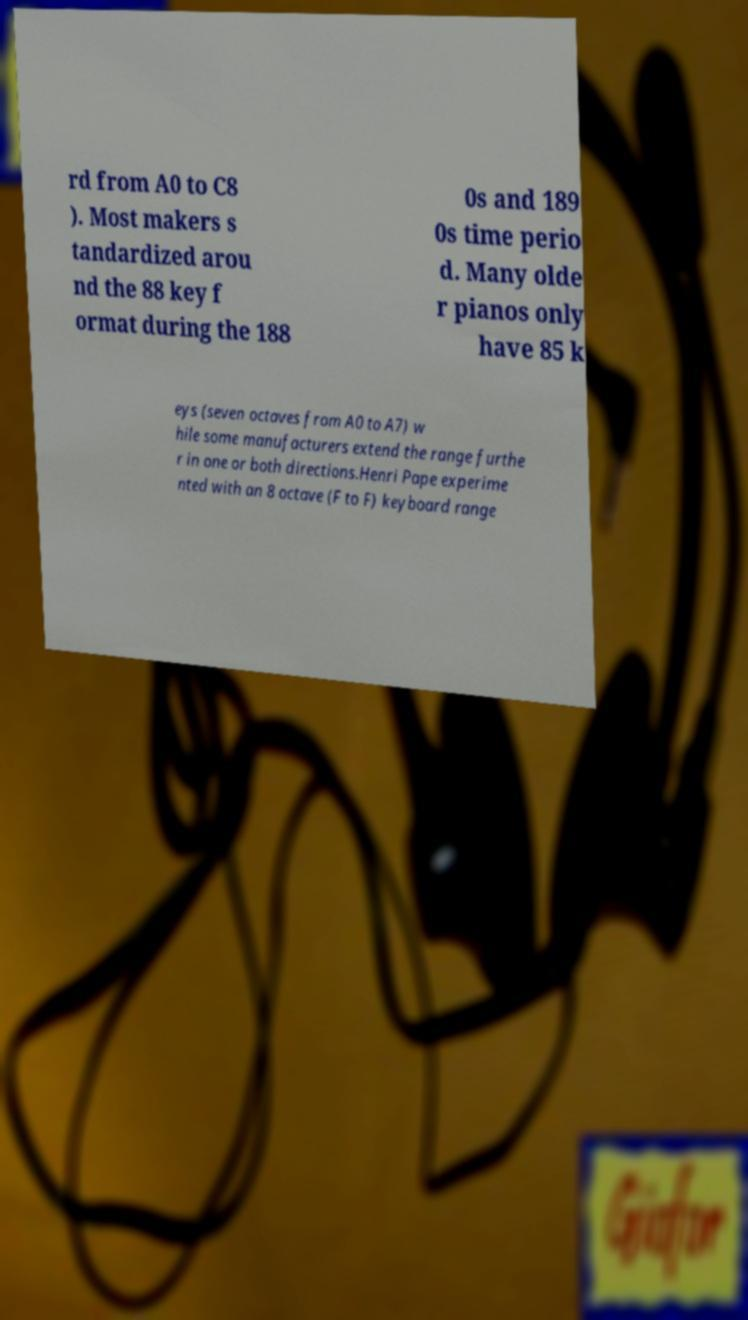There's text embedded in this image that I need extracted. Can you transcribe it verbatim? rd from A0 to C8 ). Most makers s tandardized arou nd the 88 key f ormat during the 188 0s and 189 0s time perio d. Many olde r pianos only have 85 k eys (seven octaves from A0 to A7) w hile some manufacturers extend the range furthe r in one or both directions.Henri Pape experime nted with an 8 octave (F to F) keyboard range 